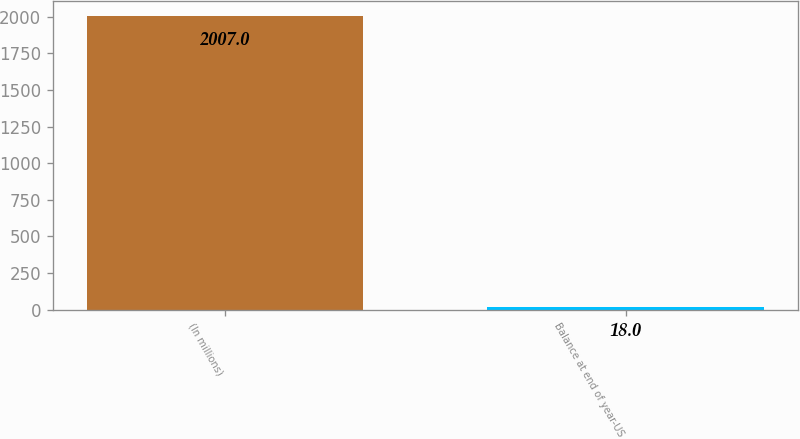Convert chart to OTSL. <chart><loc_0><loc_0><loc_500><loc_500><bar_chart><fcel>(In millions)<fcel>Balance at end of year-US<nl><fcel>2007<fcel>18<nl></chart> 